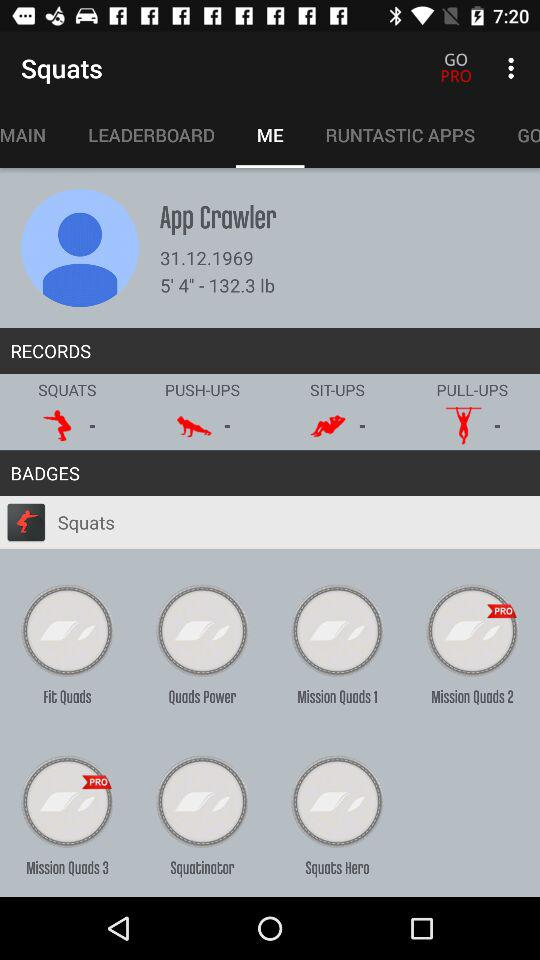Which tab is selected? The selected tab is "ME". 